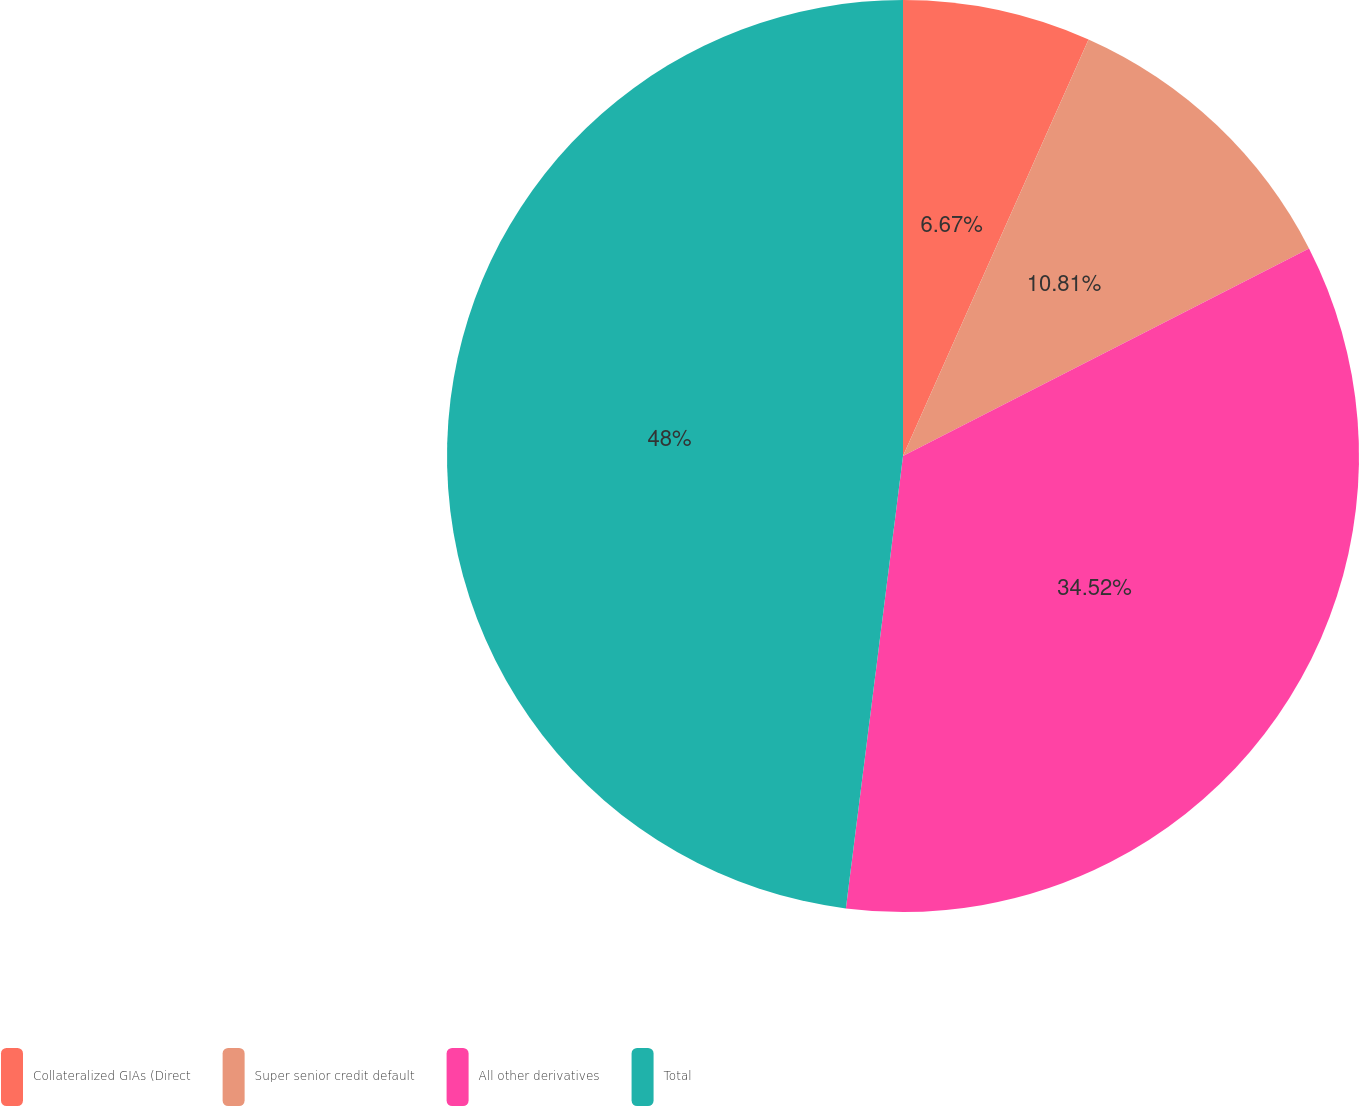Convert chart to OTSL. <chart><loc_0><loc_0><loc_500><loc_500><pie_chart><fcel>Collateralized GIAs (Direct<fcel>Super senior credit default<fcel>All other derivatives<fcel>Total<nl><fcel>6.67%<fcel>10.81%<fcel>34.52%<fcel>48.0%<nl></chart> 